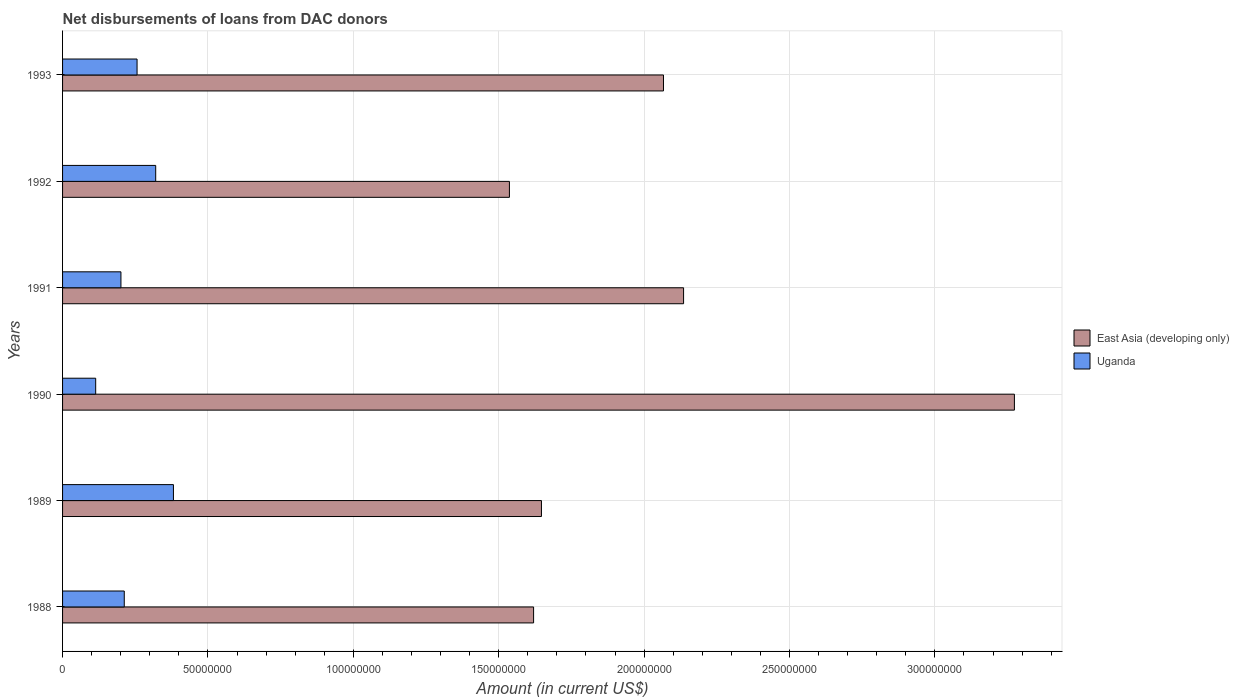How many different coloured bars are there?
Your answer should be very brief. 2. How many groups of bars are there?
Offer a very short reply. 6. Are the number of bars on each tick of the Y-axis equal?
Offer a terse response. Yes. How many bars are there on the 6th tick from the top?
Ensure brevity in your answer.  2. What is the label of the 4th group of bars from the top?
Your answer should be compact. 1990. In how many cases, is the number of bars for a given year not equal to the number of legend labels?
Keep it short and to the point. 0. What is the amount of loans disbursed in East Asia (developing only) in 1991?
Your answer should be compact. 2.14e+08. Across all years, what is the maximum amount of loans disbursed in Uganda?
Ensure brevity in your answer.  3.81e+07. Across all years, what is the minimum amount of loans disbursed in East Asia (developing only)?
Provide a succinct answer. 1.54e+08. In which year was the amount of loans disbursed in East Asia (developing only) minimum?
Offer a very short reply. 1992. What is the total amount of loans disbursed in East Asia (developing only) in the graph?
Your answer should be very brief. 1.23e+09. What is the difference between the amount of loans disbursed in Uganda in 1989 and that in 1991?
Your answer should be compact. 1.81e+07. What is the difference between the amount of loans disbursed in Uganda in 1991 and the amount of loans disbursed in East Asia (developing only) in 1989?
Give a very brief answer. -1.45e+08. What is the average amount of loans disbursed in Uganda per year?
Ensure brevity in your answer.  2.47e+07. In the year 1991, what is the difference between the amount of loans disbursed in Uganda and amount of loans disbursed in East Asia (developing only)?
Your response must be concise. -1.93e+08. What is the ratio of the amount of loans disbursed in East Asia (developing only) in 1990 to that in 1991?
Your answer should be very brief. 1.53. Is the amount of loans disbursed in Uganda in 1989 less than that in 1990?
Your answer should be compact. No. Is the difference between the amount of loans disbursed in Uganda in 1988 and 1990 greater than the difference between the amount of loans disbursed in East Asia (developing only) in 1988 and 1990?
Give a very brief answer. Yes. What is the difference between the highest and the second highest amount of loans disbursed in Uganda?
Your answer should be very brief. 6.10e+06. What is the difference between the highest and the lowest amount of loans disbursed in East Asia (developing only)?
Keep it short and to the point. 1.74e+08. Is the sum of the amount of loans disbursed in East Asia (developing only) in 1989 and 1993 greater than the maximum amount of loans disbursed in Uganda across all years?
Ensure brevity in your answer.  Yes. What does the 2nd bar from the top in 1992 represents?
Make the answer very short. East Asia (developing only). What does the 1st bar from the bottom in 1991 represents?
Your answer should be compact. East Asia (developing only). How many bars are there?
Offer a terse response. 12. What is the difference between two consecutive major ticks on the X-axis?
Your answer should be compact. 5.00e+07. Does the graph contain grids?
Your answer should be compact. Yes. What is the title of the graph?
Offer a very short reply. Net disbursements of loans from DAC donors. What is the Amount (in current US$) in East Asia (developing only) in 1988?
Keep it short and to the point. 1.62e+08. What is the Amount (in current US$) of Uganda in 1988?
Your answer should be compact. 2.12e+07. What is the Amount (in current US$) of East Asia (developing only) in 1989?
Make the answer very short. 1.65e+08. What is the Amount (in current US$) in Uganda in 1989?
Keep it short and to the point. 3.81e+07. What is the Amount (in current US$) in East Asia (developing only) in 1990?
Make the answer very short. 3.27e+08. What is the Amount (in current US$) in Uganda in 1990?
Your answer should be very brief. 1.14e+07. What is the Amount (in current US$) in East Asia (developing only) in 1991?
Offer a very short reply. 2.14e+08. What is the Amount (in current US$) of Uganda in 1991?
Give a very brief answer. 2.01e+07. What is the Amount (in current US$) in East Asia (developing only) in 1992?
Give a very brief answer. 1.54e+08. What is the Amount (in current US$) in Uganda in 1992?
Provide a succinct answer. 3.20e+07. What is the Amount (in current US$) of East Asia (developing only) in 1993?
Your response must be concise. 2.07e+08. What is the Amount (in current US$) of Uganda in 1993?
Ensure brevity in your answer.  2.56e+07. Across all years, what is the maximum Amount (in current US$) of East Asia (developing only)?
Give a very brief answer. 3.27e+08. Across all years, what is the maximum Amount (in current US$) in Uganda?
Give a very brief answer. 3.81e+07. Across all years, what is the minimum Amount (in current US$) of East Asia (developing only)?
Your answer should be very brief. 1.54e+08. Across all years, what is the minimum Amount (in current US$) of Uganda?
Make the answer very short. 1.14e+07. What is the total Amount (in current US$) of East Asia (developing only) in the graph?
Your answer should be compact. 1.23e+09. What is the total Amount (in current US$) of Uganda in the graph?
Offer a very short reply. 1.48e+08. What is the difference between the Amount (in current US$) of East Asia (developing only) in 1988 and that in 1989?
Give a very brief answer. -2.70e+06. What is the difference between the Amount (in current US$) in Uganda in 1988 and that in 1989?
Offer a terse response. -1.69e+07. What is the difference between the Amount (in current US$) of East Asia (developing only) in 1988 and that in 1990?
Provide a short and direct response. -1.65e+08. What is the difference between the Amount (in current US$) in Uganda in 1988 and that in 1990?
Offer a very short reply. 9.83e+06. What is the difference between the Amount (in current US$) of East Asia (developing only) in 1988 and that in 1991?
Provide a succinct answer. -5.16e+07. What is the difference between the Amount (in current US$) of Uganda in 1988 and that in 1991?
Your answer should be compact. 1.14e+06. What is the difference between the Amount (in current US$) of East Asia (developing only) in 1988 and that in 1992?
Provide a short and direct response. 8.31e+06. What is the difference between the Amount (in current US$) of Uganda in 1988 and that in 1992?
Your response must be concise. -1.08e+07. What is the difference between the Amount (in current US$) of East Asia (developing only) in 1988 and that in 1993?
Provide a succinct answer. -4.47e+07. What is the difference between the Amount (in current US$) of Uganda in 1988 and that in 1993?
Offer a terse response. -4.40e+06. What is the difference between the Amount (in current US$) in East Asia (developing only) in 1989 and that in 1990?
Keep it short and to the point. -1.63e+08. What is the difference between the Amount (in current US$) of Uganda in 1989 and that in 1990?
Your response must be concise. 2.67e+07. What is the difference between the Amount (in current US$) in East Asia (developing only) in 1989 and that in 1991?
Your answer should be compact. -4.89e+07. What is the difference between the Amount (in current US$) in Uganda in 1989 and that in 1991?
Ensure brevity in your answer.  1.81e+07. What is the difference between the Amount (in current US$) of East Asia (developing only) in 1989 and that in 1992?
Offer a terse response. 1.10e+07. What is the difference between the Amount (in current US$) of Uganda in 1989 and that in 1992?
Make the answer very short. 6.10e+06. What is the difference between the Amount (in current US$) in East Asia (developing only) in 1989 and that in 1993?
Provide a succinct answer. -4.20e+07. What is the difference between the Amount (in current US$) of Uganda in 1989 and that in 1993?
Offer a terse response. 1.25e+07. What is the difference between the Amount (in current US$) of East Asia (developing only) in 1990 and that in 1991?
Keep it short and to the point. 1.14e+08. What is the difference between the Amount (in current US$) of Uganda in 1990 and that in 1991?
Your answer should be very brief. -8.68e+06. What is the difference between the Amount (in current US$) in East Asia (developing only) in 1990 and that in 1992?
Ensure brevity in your answer.  1.74e+08. What is the difference between the Amount (in current US$) of Uganda in 1990 and that in 1992?
Your answer should be compact. -2.06e+07. What is the difference between the Amount (in current US$) in East Asia (developing only) in 1990 and that in 1993?
Make the answer very short. 1.21e+08. What is the difference between the Amount (in current US$) in Uganda in 1990 and that in 1993?
Your answer should be very brief. -1.42e+07. What is the difference between the Amount (in current US$) in East Asia (developing only) in 1991 and that in 1992?
Ensure brevity in your answer.  5.99e+07. What is the difference between the Amount (in current US$) in Uganda in 1991 and that in 1992?
Offer a terse response. -1.20e+07. What is the difference between the Amount (in current US$) of East Asia (developing only) in 1991 and that in 1993?
Ensure brevity in your answer.  6.91e+06. What is the difference between the Amount (in current US$) of Uganda in 1991 and that in 1993?
Keep it short and to the point. -5.54e+06. What is the difference between the Amount (in current US$) of East Asia (developing only) in 1992 and that in 1993?
Offer a terse response. -5.30e+07. What is the difference between the Amount (in current US$) of Uganda in 1992 and that in 1993?
Your response must be concise. 6.41e+06. What is the difference between the Amount (in current US$) of East Asia (developing only) in 1988 and the Amount (in current US$) of Uganda in 1989?
Provide a succinct answer. 1.24e+08. What is the difference between the Amount (in current US$) of East Asia (developing only) in 1988 and the Amount (in current US$) of Uganda in 1990?
Keep it short and to the point. 1.51e+08. What is the difference between the Amount (in current US$) in East Asia (developing only) in 1988 and the Amount (in current US$) in Uganda in 1991?
Offer a very short reply. 1.42e+08. What is the difference between the Amount (in current US$) in East Asia (developing only) in 1988 and the Amount (in current US$) in Uganda in 1992?
Offer a terse response. 1.30e+08. What is the difference between the Amount (in current US$) of East Asia (developing only) in 1988 and the Amount (in current US$) of Uganda in 1993?
Keep it short and to the point. 1.36e+08. What is the difference between the Amount (in current US$) in East Asia (developing only) in 1989 and the Amount (in current US$) in Uganda in 1990?
Your answer should be compact. 1.53e+08. What is the difference between the Amount (in current US$) of East Asia (developing only) in 1989 and the Amount (in current US$) of Uganda in 1991?
Your answer should be very brief. 1.45e+08. What is the difference between the Amount (in current US$) in East Asia (developing only) in 1989 and the Amount (in current US$) in Uganda in 1992?
Your answer should be very brief. 1.33e+08. What is the difference between the Amount (in current US$) in East Asia (developing only) in 1989 and the Amount (in current US$) in Uganda in 1993?
Provide a succinct answer. 1.39e+08. What is the difference between the Amount (in current US$) in East Asia (developing only) in 1990 and the Amount (in current US$) in Uganda in 1991?
Ensure brevity in your answer.  3.07e+08. What is the difference between the Amount (in current US$) in East Asia (developing only) in 1990 and the Amount (in current US$) in Uganda in 1992?
Keep it short and to the point. 2.95e+08. What is the difference between the Amount (in current US$) of East Asia (developing only) in 1990 and the Amount (in current US$) of Uganda in 1993?
Provide a succinct answer. 3.02e+08. What is the difference between the Amount (in current US$) of East Asia (developing only) in 1991 and the Amount (in current US$) of Uganda in 1992?
Provide a short and direct response. 1.82e+08. What is the difference between the Amount (in current US$) in East Asia (developing only) in 1991 and the Amount (in current US$) in Uganda in 1993?
Ensure brevity in your answer.  1.88e+08. What is the difference between the Amount (in current US$) in East Asia (developing only) in 1992 and the Amount (in current US$) in Uganda in 1993?
Provide a short and direct response. 1.28e+08. What is the average Amount (in current US$) of East Asia (developing only) per year?
Your answer should be very brief. 2.05e+08. What is the average Amount (in current US$) of Uganda per year?
Your answer should be compact. 2.47e+07. In the year 1988, what is the difference between the Amount (in current US$) of East Asia (developing only) and Amount (in current US$) of Uganda?
Make the answer very short. 1.41e+08. In the year 1989, what is the difference between the Amount (in current US$) in East Asia (developing only) and Amount (in current US$) in Uganda?
Offer a very short reply. 1.27e+08. In the year 1990, what is the difference between the Amount (in current US$) of East Asia (developing only) and Amount (in current US$) of Uganda?
Make the answer very short. 3.16e+08. In the year 1991, what is the difference between the Amount (in current US$) of East Asia (developing only) and Amount (in current US$) of Uganda?
Offer a terse response. 1.93e+08. In the year 1992, what is the difference between the Amount (in current US$) in East Asia (developing only) and Amount (in current US$) in Uganda?
Your response must be concise. 1.22e+08. In the year 1993, what is the difference between the Amount (in current US$) in East Asia (developing only) and Amount (in current US$) in Uganda?
Offer a very short reply. 1.81e+08. What is the ratio of the Amount (in current US$) in East Asia (developing only) in 1988 to that in 1989?
Offer a very short reply. 0.98. What is the ratio of the Amount (in current US$) in Uganda in 1988 to that in 1989?
Your response must be concise. 0.56. What is the ratio of the Amount (in current US$) in East Asia (developing only) in 1988 to that in 1990?
Your response must be concise. 0.49. What is the ratio of the Amount (in current US$) in Uganda in 1988 to that in 1990?
Make the answer very short. 1.86. What is the ratio of the Amount (in current US$) of East Asia (developing only) in 1988 to that in 1991?
Ensure brevity in your answer.  0.76. What is the ratio of the Amount (in current US$) of Uganda in 1988 to that in 1991?
Provide a short and direct response. 1.06. What is the ratio of the Amount (in current US$) of East Asia (developing only) in 1988 to that in 1992?
Your answer should be very brief. 1.05. What is the ratio of the Amount (in current US$) in Uganda in 1988 to that in 1992?
Ensure brevity in your answer.  0.66. What is the ratio of the Amount (in current US$) in East Asia (developing only) in 1988 to that in 1993?
Give a very brief answer. 0.78. What is the ratio of the Amount (in current US$) of Uganda in 1988 to that in 1993?
Give a very brief answer. 0.83. What is the ratio of the Amount (in current US$) in East Asia (developing only) in 1989 to that in 1990?
Your answer should be very brief. 0.5. What is the ratio of the Amount (in current US$) in Uganda in 1989 to that in 1990?
Make the answer very short. 3.35. What is the ratio of the Amount (in current US$) of East Asia (developing only) in 1989 to that in 1991?
Provide a succinct answer. 0.77. What is the ratio of the Amount (in current US$) in Uganda in 1989 to that in 1991?
Offer a very short reply. 1.9. What is the ratio of the Amount (in current US$) in East Asia (developing only) in 1989 to that in 1992?
Give a very brief answer. 1.07. What is the ratio of the Amount (in current US$) of Uganda in 1989 to that in 1992?
Give a very brief answer. 1.19. What is the ratio of the Amount (in current US$) in East Asia (developing only) in 1989 to that in 1993?
Provide a succinct answer. 0.8. What is the ratio of the Amount (in current US$) of Uganda in 1989 to that in 1993?
Offer a terse response. 1.49. What is the ratio of the Amount (in current US$) in East Asia (developing only) in 1990 to that in 1991?
Provide a short and direct response. 1.53. What is the ratio of the Amount (in current US$) of Uganda in 1990 to that in 1991?
Keep it short and to the point. 0.57. What is the ratio of the Amount (in current US$) of East Asia (developing only) in 1990 to that in 1992?
Make the answer very short. 2.13. What is the ratio of the Amount (in current US$) of Uganda in 1990 to that in 1992?
Provide a short and direct response. 0.36. What is the ratio of the Amount (in current US$) in East Asia (developing only) in 1990 to that in 1993?
Give a very brief answer. 1.58. What is the ratio of the Amount (in current US$) in Uganda in 1990 to that in 1993?
Offer a very short reply. 0.44. What is the ratio of the Amount (in current US$) in East Asia (developing only) in 1991 to that in 1992?
Provide a short and direct response. 1.39. What is the ratio of the Amount (in current US$) in Uganda in 1991 to that in 1992?
Offer a very short reply. 0.63. What is the ratio of the Amount (in current US$) in East Asia (developing only) in 1991 to that in 1993?
Make the answer very short. 1.03. What is the ratio of the Amount (in current US$) of Uganda in 1991 to that in 1993?
Your response must be concise. 0.78. What is the ratio of the Amount (in current US$) of East Asia (developing only) in 1992 to that in 1993?
Your response must be concise. 0.74. What is the ratio of the Amount (in current US$) in Uganda in 1992 to that in 1993?
Make the answer very short. 1.25. What is the difference between the highest and the second highest Amount (in current US$) in East Asia (developing only)?
Give a very brief answer. 1.14e+08. What is the difference between the highest and the second highest Amount (in current US$) in Uganda?
Ensure brevity in your answer.  6.10e+06. What is the difference between the highest and the lowest Amount (in current US$) of East Asia (developing only)?
Provide a short and direct response. 1.74e+08. What is the difference between the highest and the lowest Amount (in current US$) in Uganda?
Make the answer very short. 2.67e+07. 